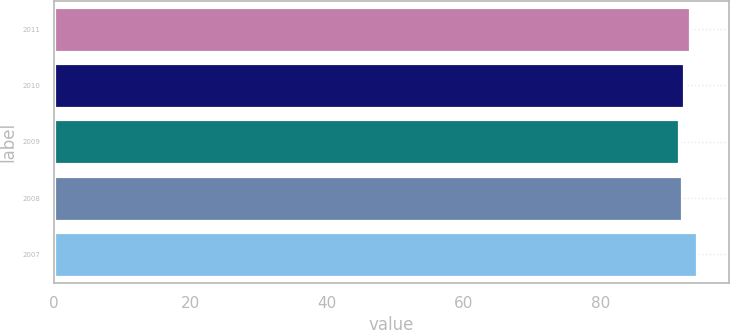Convert chart to OTSL. <chart><loc_0><loc_0><loc_500><loc_500><bar_chart><fcel>2011<fcel>2010<fcel>2009<fcel>2008<fcel>2007<nl><fcel>93.1<fcel>92.16<fcel>91.5<fcel>91.9<fcel>94.1<nl></chart> 